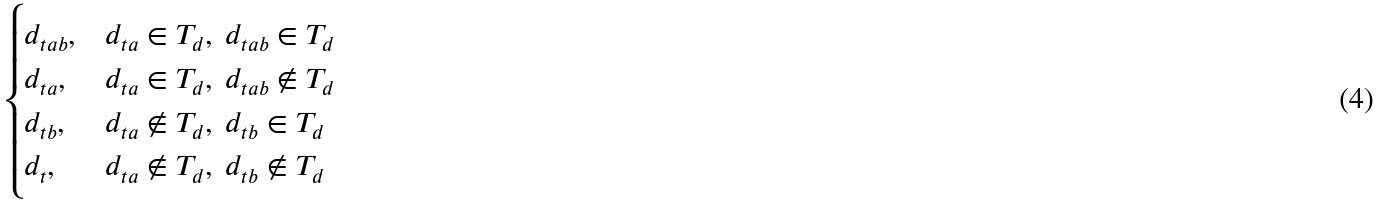Convert formula to latex. <formula><loc_0><loc_0><loc_500><loc_500>\begin{cases} d _ { t a b } , & d _ { t a } \in T _ { d } , \ d _ { t a b } \in T _ { d } \\ d _ { t a } , & d _ { t a } \in T _ { d } , \ d _ { t a b } \not \in T _ { d } \\ d _ { t b } , & d _ { t a } \not \in T _ { d } , \ d _ { t b } \in T _ { d } \\ d _ { t } , & d _ { t a } \not \in T _ { d } , \ d _ { t b } \not \in T _ { d } \end{cases}</formula> 